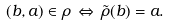<formula> <loc_0><loc_0><loc_500><loc_500>( b , a ) \in \rho \, \Leftrightarrow \, \tilde { \rho } ( b ) = a .</formula> 